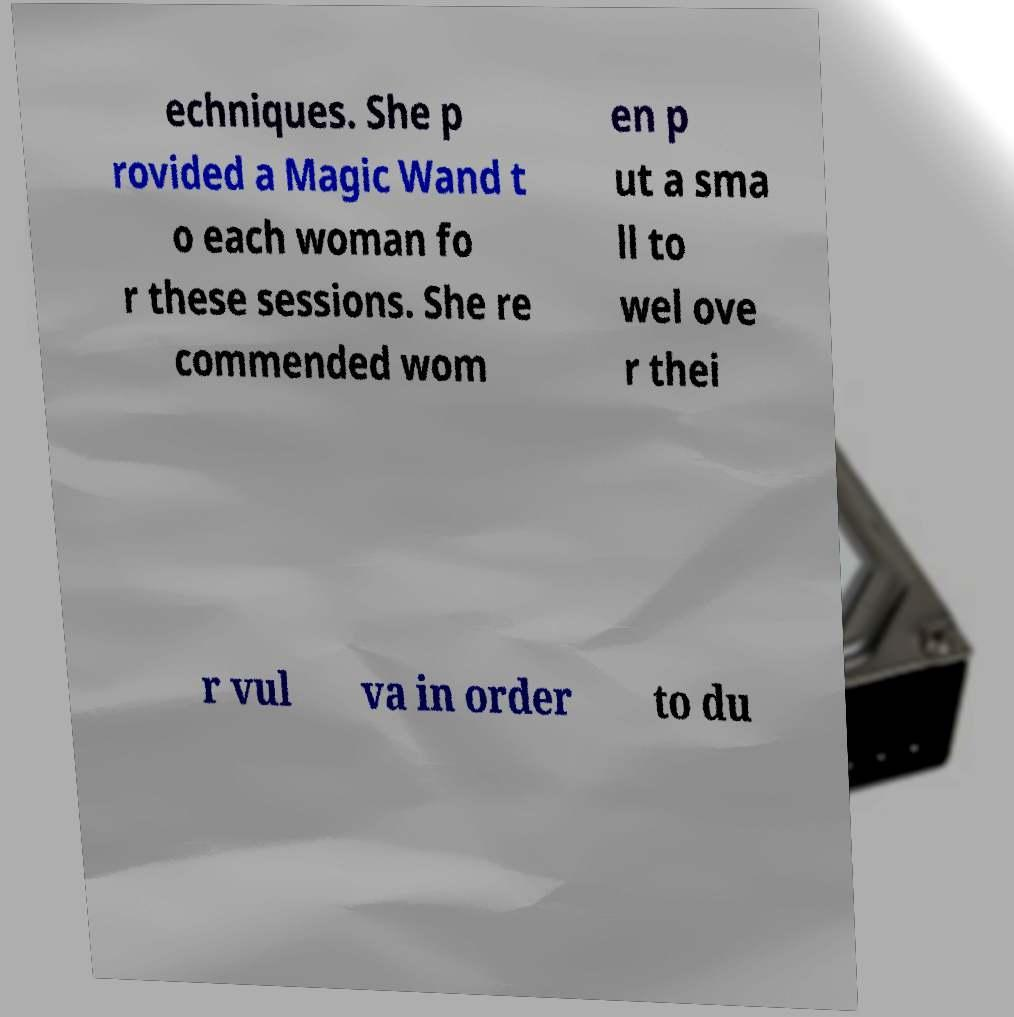For documentation purposes, I need the text within this image transcribed. Could you provide that? echniques. She p rovided a Magic Wand t o each woman fo r these sessions. She re commended wom en p ut a sma ll to wel ove r thei r vul va in order to du 